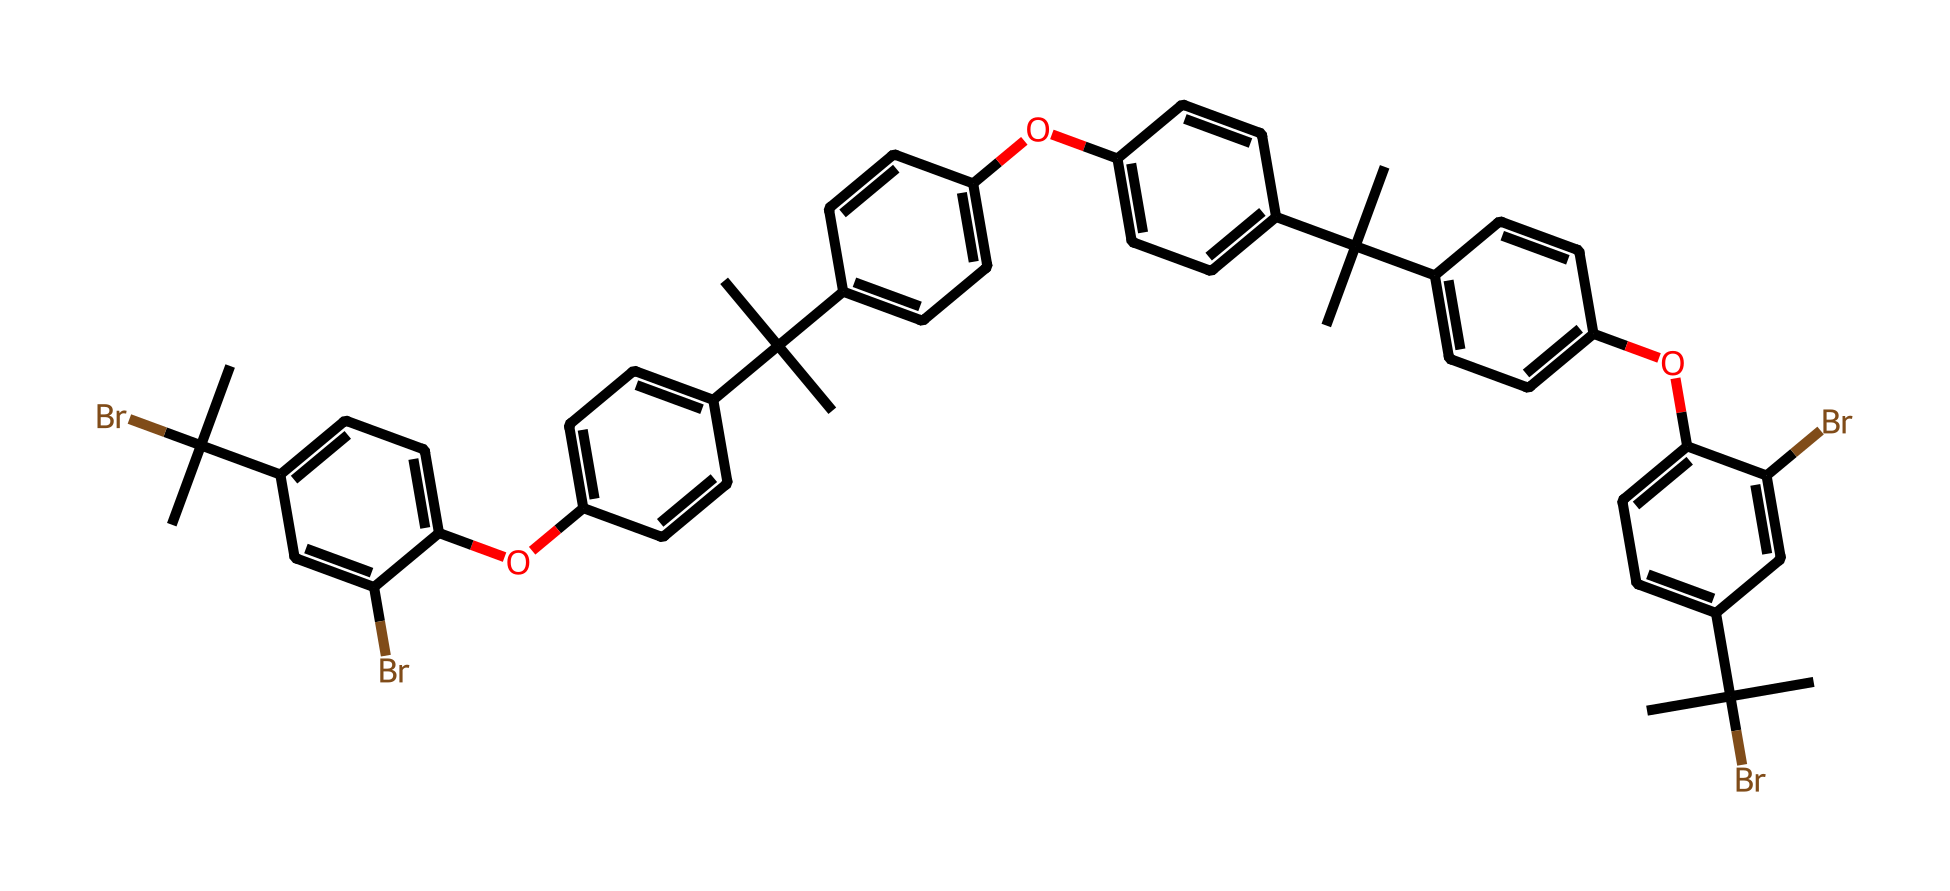What is the primary function of this polymer? The polymer's structure includes bromine atoms, which are typically used to enhance flame retardancy. This indicates its primary function to reduce flammability.
Answer: flame retardancy How many bromine atoms are present in the structure? By analyzing the SMILES representation, there are two occurrences of "Br", indicating that there are two bromine atoms in the polymer structure.
Answer: two What type of bonds are most prevalent in this polymer? The presence of several carbon-carbon (C-C) and carbon-oxygen (C-O) bonds can be inferred from the structure, indicating that these are the predominant bond types in this polymer's composition.
Answer: carbon-carbon and carbon-oxygen What is the role of the alkyl substituents in the polymer? The alkyl substituents, which are represented as "CC(C)", enhance the hydrophobic character of the polymer and contribute to its mechanical properties, making it more suited for applications in office furniture.
Answer: enhance hydrophobic character How does the presence of phenolic groups influence the properties of this polymer? Phenolic groups, indicated by the aromatic rings connected to oxygen atoms, contribute to thermal stability and increased flame resistance, essential for compliance with safety standards in office settings.
Answer: thermal stability and flame resistance What can be inferred about the overall shape of the polymer based on its structure? The branched structure due to multiple alkyl groups typically results in a more complex three-dimensional configuration, which affects the material's processing and application properties in furniture.
Answer: complex three-dimensional configuration What is the significance of the ether linkages in this polymer? Ether linkages, indicated by the connections of oxygen to adjacent carbon atoms, generally improve flexibility and impact resistance, which are beneficial for durable furniture applications.
Answer: improve flexibility and impact resistance 